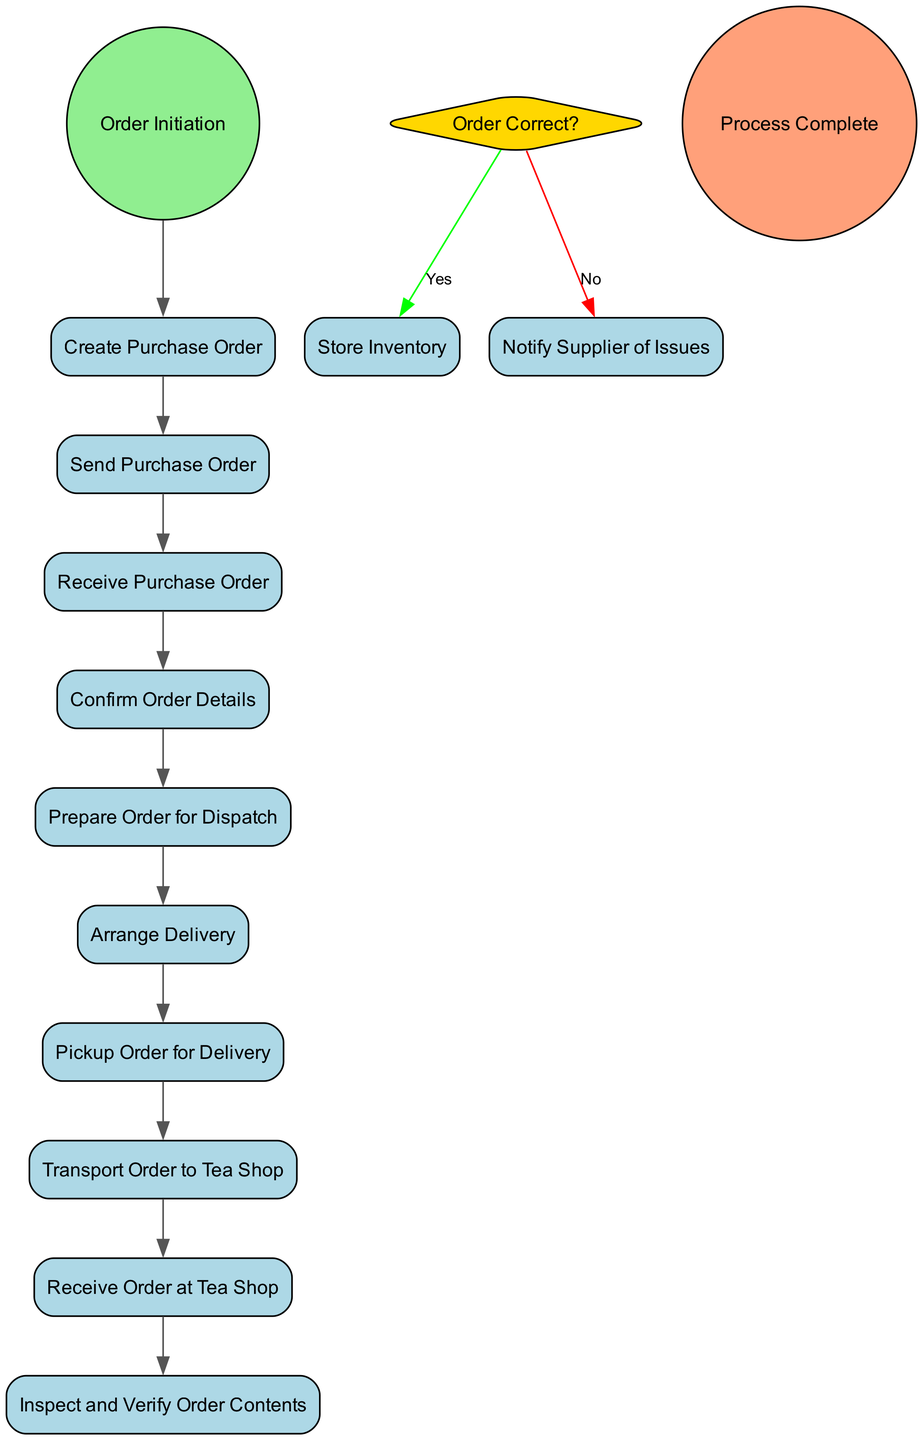What is the first activity in the process? The first activity in the process is labeled "Order Initiation," which is the starting point of the workflow for ordering and delivery.
Answer: Order Initiation Who receives the purchase order? The purchase order is received by the "Supplier" as indicated in the diagram.
Answer: Supplier How many activities follow "Create Purchase Order"? The activities following "Create Purchase Order" are "Send Purchase Order," "Receive Purchase Order," "Confirm Order Details," "Prepare Order for Dispatch," and "Arrange Delivery," totaling five activities.
Answer: Five What does the "Tea Shop Owner" do if the order is not correct? If the order is not correct, the "Tea Shop Owner" will "Notify Supplier of Issues" according to the decision flow from "Order Correct?"
Answer: Notify Supplier of Issues What role does the logistics company play in the process? The logistics company is responsible for "Pickup Order for Delivery" and "Transport Order to Tea Shop," indicating its role is to manage the transportation of orders.
Answer: Transport Order to Tea Shop What decision is made regarding the order? The decision made is, "Order Correct?" which determines the subsequent action based on whether the order contents are correct.
Answer: Order Correct? Which activity occurs last in the process? The final activity that completes the process is the "Process Complete," signaling the end after all prior steps have been executed.
Answer: Process Complete What happens after "Arrange Delivery"? After "Arrange Delivery," the next activity is "Pickup Order for Delivery," indicating the transition from supplier arrangements to logistics involvement.
Answer: Pickup Order for Delivery How many roles are represented in the diagram? There are three roles represented in the diagram: "Tea Shop Owner," "Supplier," and "Logistics Company."
Answer: Three 